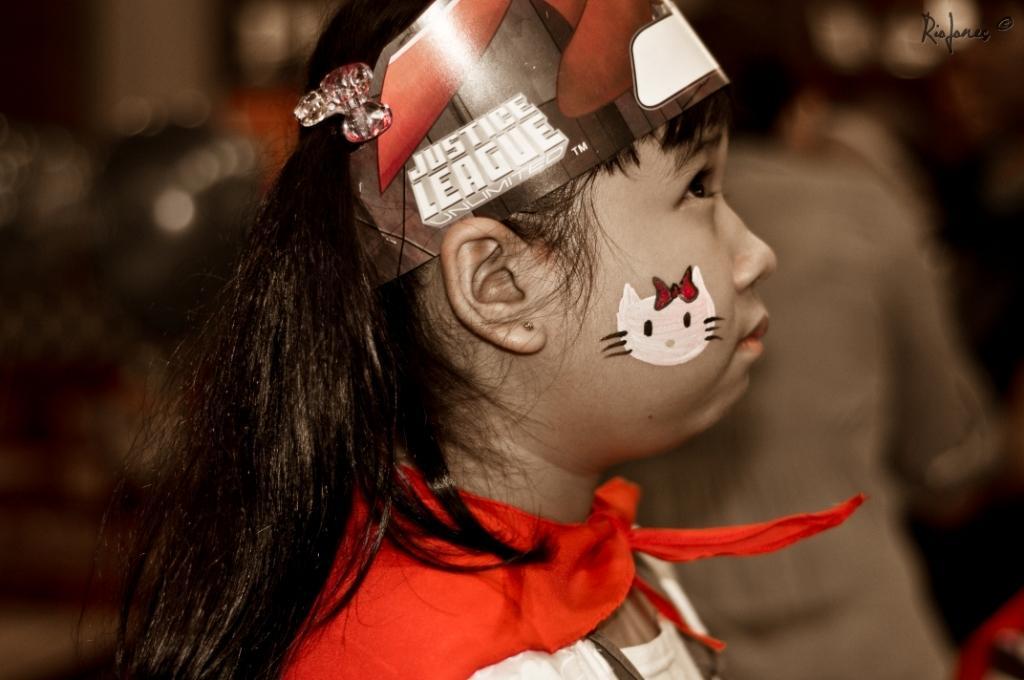Can you describe this image briefly? Here we can see a girl and there is a blur background. 